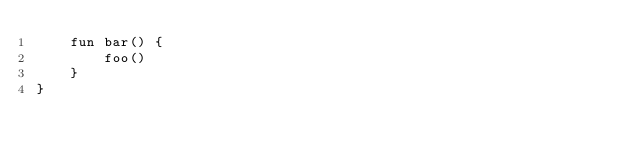Convert code to text. <code><loc_0><loc_0><loc_500><loc_500><_Kotlin_>    fun bar() {
        foo()
    }
}</code> 